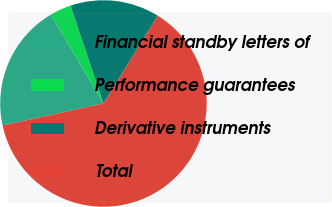Convert chart to OTSL. <chart><loc_0><loc_0><loc_500><loc_500><pie_chart><fcel>Financial standby letters of<fcel>Performance guarantees<fcel>Derivative instruments<fcel>Total<nl><fcel>19.92%<fcel>3.35%<fcel>13.98%<fcel>62.75%<nl></chart> 